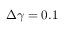<formula> <loc_0><loc_0><loc_500><loc_500>\Delta \gamma = 0 . 1</formula> 